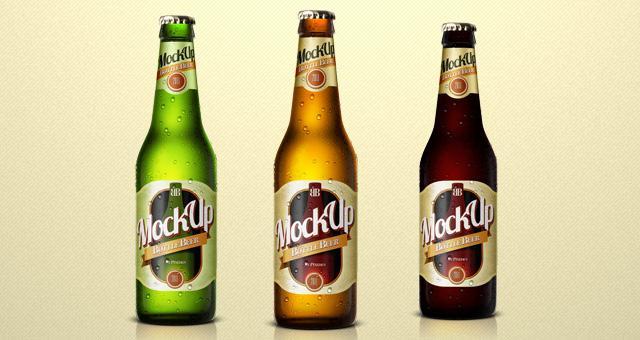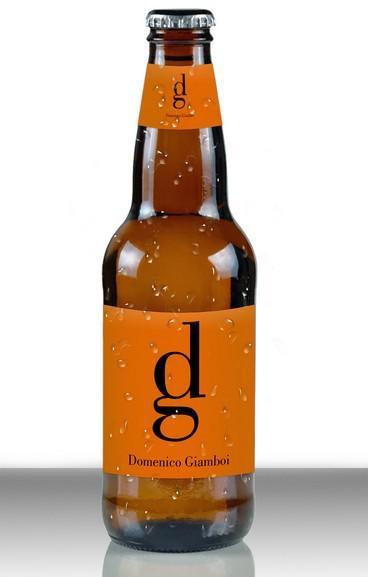The first image is the image on the left, the second image is the image on the right. For the images shown, is this caption "There are no less than three beer bottles" true? Answer yes or no. Yes. The first image is the image on the left, the second image is the image on the right. Given the left and right images, does the statement "there are at least two bottles in the image on the left" hold true? Answer yes or no. Yes. 